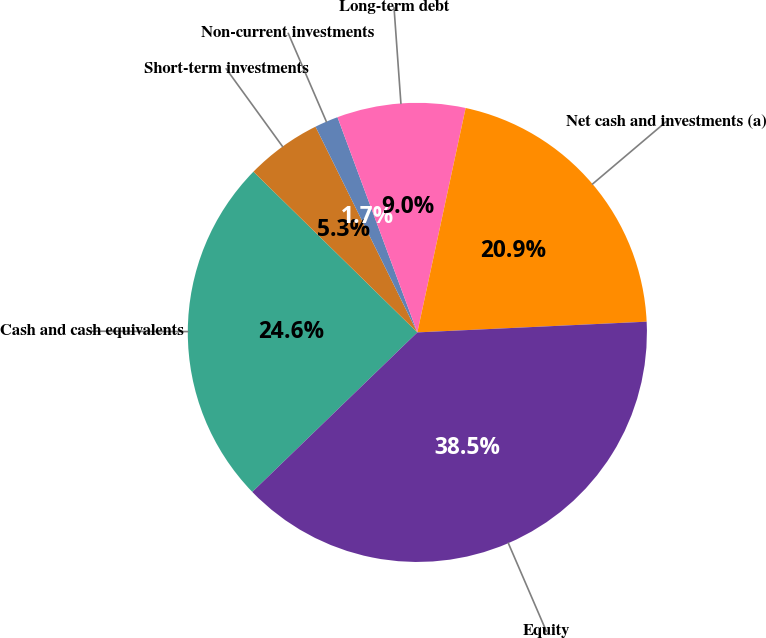Convert chart to OTSL. <chart><loc_0><loc_0><loc_500><loc_500><pie_chart><fcel>Cash and cash equivalents<fcel>Short-term investments<fcel>Non-current investments<fcel>Long-term debt<fcel>Net cash and investments (a)<fcel>Equity<nl><fcel>24.57%<fcel>5.34%<fcel>1.66%<fcel>9.03%<fcel>20.88%<fcel>38.51%<nl></chart> 